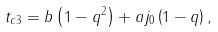<formula> <loc_0><loc_0><loc_500><loc_500>t _ { c 3 } = b \left ( 1 - q ^ { 2 } \right ) + a j _ { 0 } \left ( 1 - q \right ) ,</formula> 